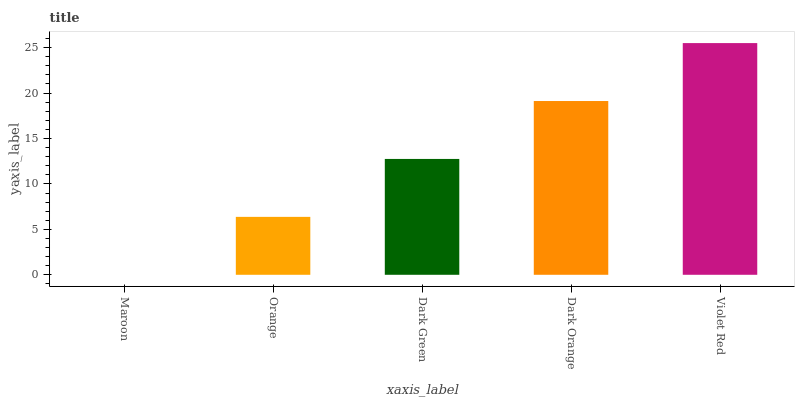Is Maroon the minimum?
Answer yes or no. Yes. Is Violet Red the maximum?
Answer yes or no. Yes. Is Orange the minimum?
Answer yes or no. No. Is Orange the maximum?
Answer yes or no. No. Is Orange greater than Maroon?
Answer yes or no. Yes. Is Maroon less than Orange?
Answer yes or no. Yes. Is Maroon greater than Orange?
Answer yes or no. No. Is Orange less than Maroon?
Answer yes or no. No. Is Dark Green the high median?
Answer yes or no. Yes. Is Dark Green the low median?
Answer yes or no. Yes. Is Orange the high median?
Answer yes or no. No. Is Violet Red the low median?
Answer yes or no. No. 